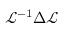<formula> <loc_0><loc_0><loc_500><loc_500>{ \mathcal { L } } ^ { - 1 } { \Delta \mathcal { L } }</formula> 